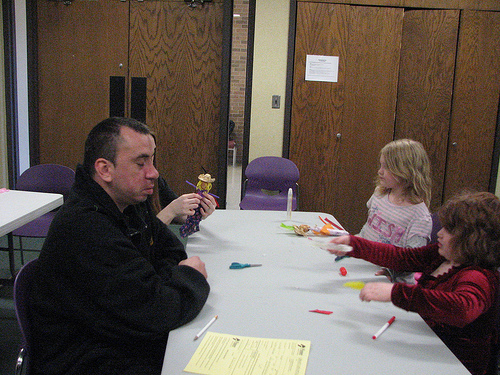<image>
Is there a man above the table? No. The man is not positioned above the table. The vertical arrangement shows a different relationship. 